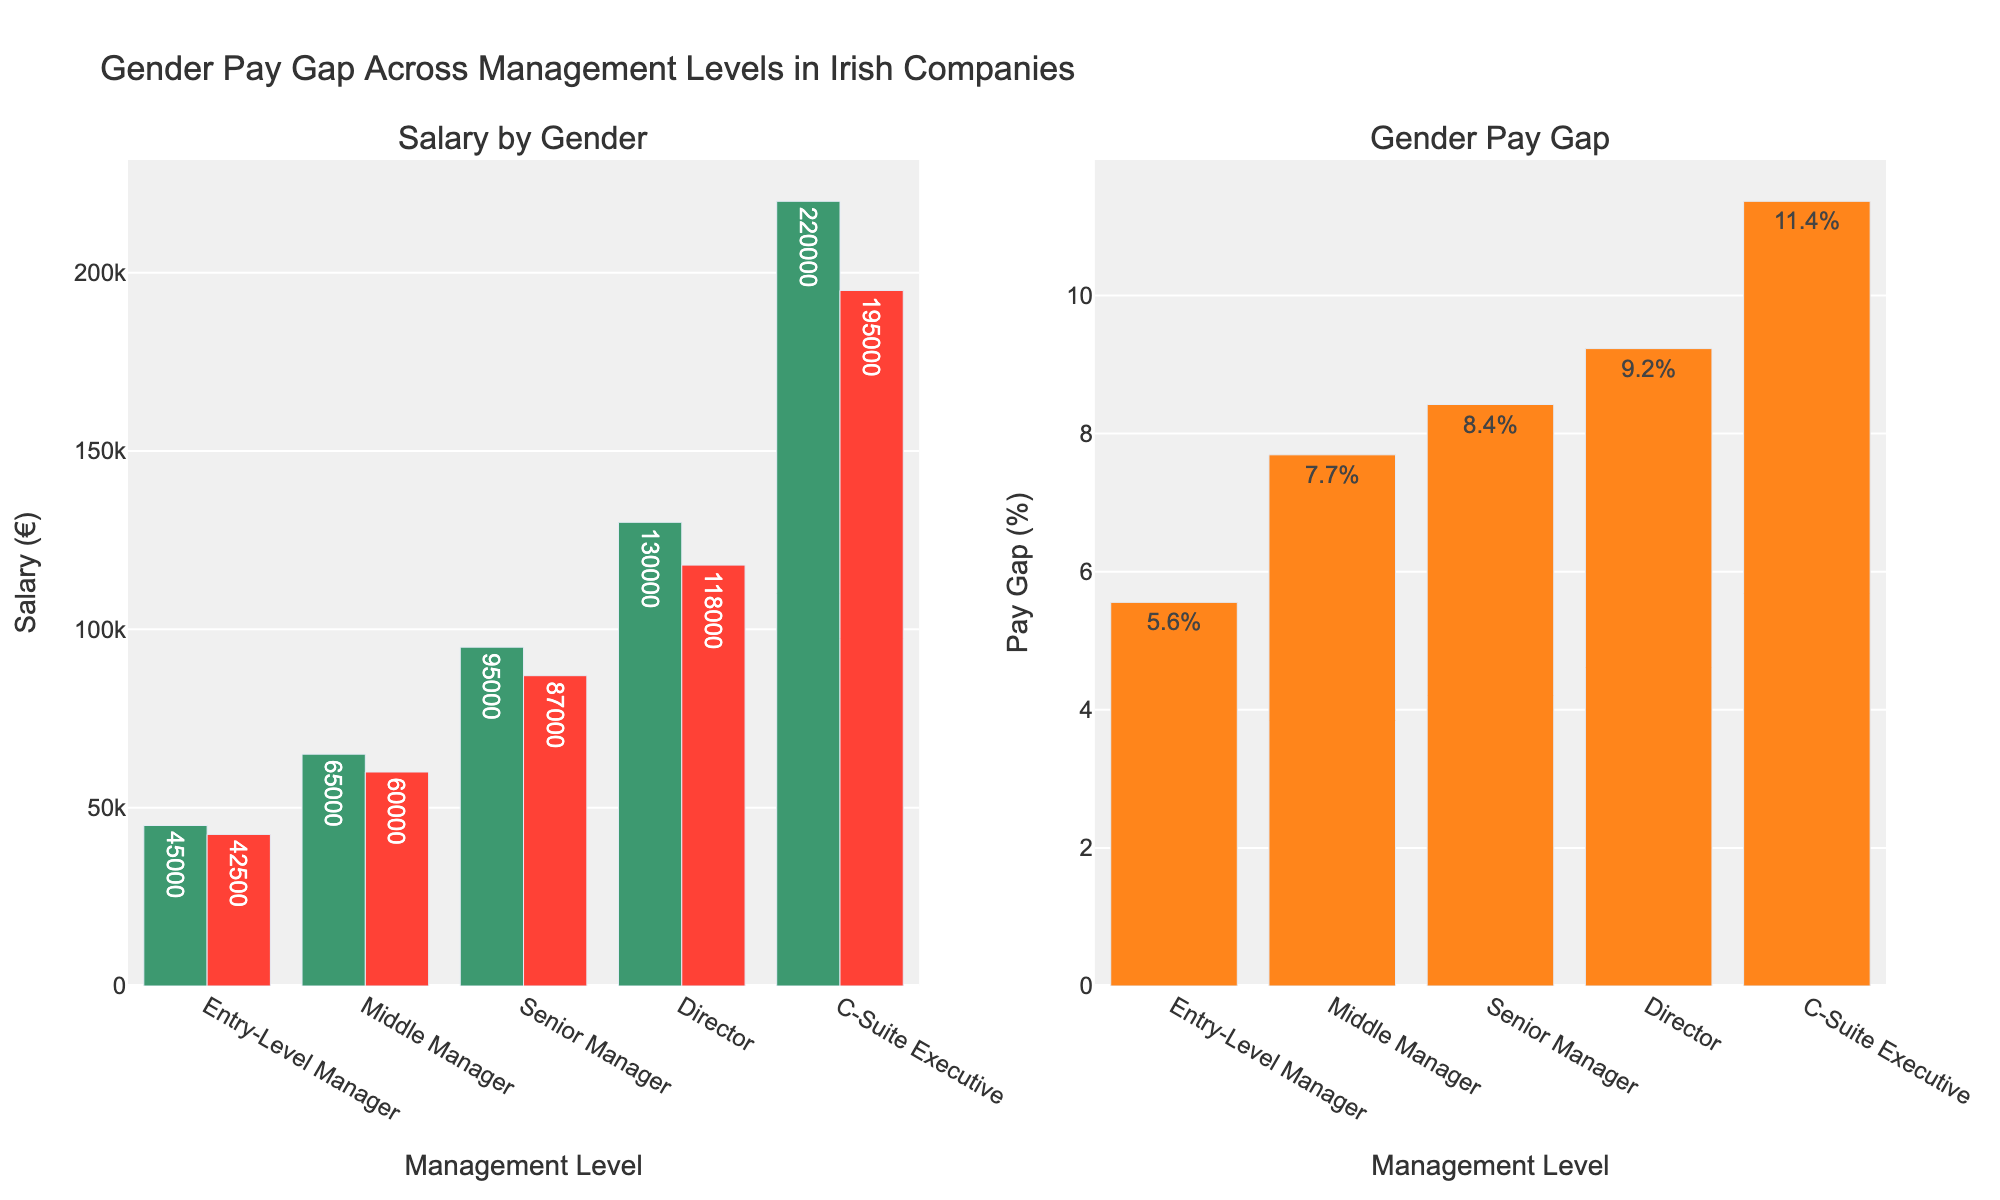What is the title of the figure? The title is usually located at the top of the figure. In this case, it states, "Gender Pay Gap Across Management Levels in Irish Companies."
Answer: Gender Pay Gap Across Management Levels in Irish Companies How many management levels are displayed in the figure? Count the number of unique management levels listed on the x-axis of the bar charts.
Answer: 5 What are the salary values for Entry-Level Managers by gender? Refer to the bars corresponding to Entry-Level Managers in the Salary by Gender subplot to find the numerical values.
Answer: Male: €45,000, Female: €42,500 Which management level shows the highest gender pay gap percentage and what is it? Look at the bars in the Gender Pay Gap (%) subplot and identify the bar that reaches the highest value, then read its label.
Answer: C-Suite Executive, 11.4% What is the difference in salary between Male and Female Senior Managers? Find the salary for Male Senior Managers and Female Senior Managers in the Salary by Gender subplot, then subtract the Female salary from the Male salary: €95,000 - €87,000.
Answer: €8,000 What is the average salary for Male and Female Directors combined? Add the salary values for Male and Female Directors and then divide by 2: (€130,000 + €118,000) / 2.
Answer: €124,000 Which gender has a lower average salary across all management levels? Calculate the average by summing all salary values for each gender and dividing by the number of management levels. For Males: (€45,000 + €65,000 + €95,000 + €130,000 + €220,000) / 5. For Females: (€42,500 + €60,000 + €87,000 + €118,000 + €195,000) / 5. Compare the two averages.
Answer: Female How much is the gender pay gap in absolute terms for Middle Managers? Refer to the Salary by Gender subplot to find the salaries for Male and Female Middle Managers and then subtract the Female salary from the Male salary.
Answer: €5,000 Which management level has the smallest gender pay gap and what is the percentage? Look at the Gender Pay Gap (%) subplot and identify the bar with the smallest value, then read its label.
Answer: Entry-Level Manager, 5.6% What is the cumulative pay gap percentage across all levels of management? Sum the percentages from the Gender Pay Gap (%) subplot: 5.6% + 7.7% + 8.4% + 9.2% + 11.4%.
Answer: 42.3% 